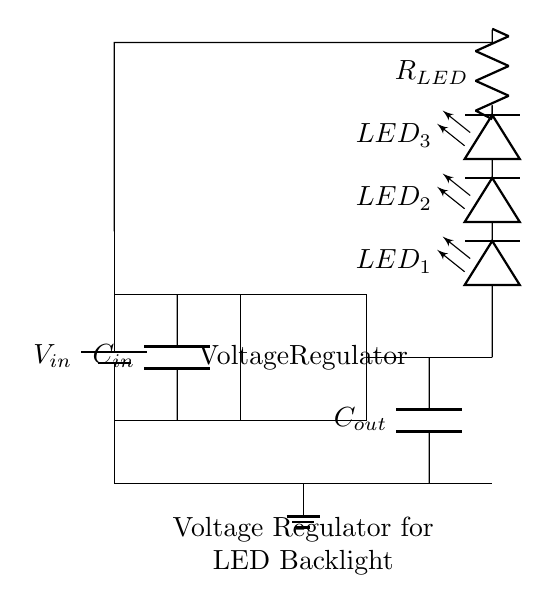What is the input voltage for this circuit? The input voltage, denoted as V in, is represented at the battery symbol on the left side of the circuit. It's the source that powers the voltage regulator.
Answer: V in What is the purpose of the capacitor labeled C in? The capacitor C in is used to filter and stabilize the input voltage to the voltage regulator. It reduces voltage fluctuations and ensures a steady voltage supply.
Answer: Filtering input How many LEDs are shown in the circuit? The circuit diagram shows a sequence of three LEDs connected in series, which is indicated by the labels LED 1, LED 2, and LED 3 next to the LED symbols.
Answer: Three What is the role of the resistor labeled R LED? The resistor R LED limits the current flowing through the LED string, preventing damage to the LEDs by ensuring the current stays within safe operating limits.
Answer: Current limiting What is the output component of this voltage regulator circuit? The output component is the arrangement of the LEDs and the resistor connected after the voltage regulator, which demonstrates the load powered by the regulator.
Answer: LED string What is the output voltage type from the voltage regulator? The output voltage type is typically regulated or stable voltage, which is shown coming out from the voltage regulator marked within the rectangle, ensuring consistent voltage for the LEDs.
Answer: Regulated voltage What is the purpose of the capacitor labeled C out? The capacitor C out is used to smooth the output voltage from the voltage regulator, helping to remove any noise and ripple from the power supplied to the load (LEDs).
Answer: Smoothing output 